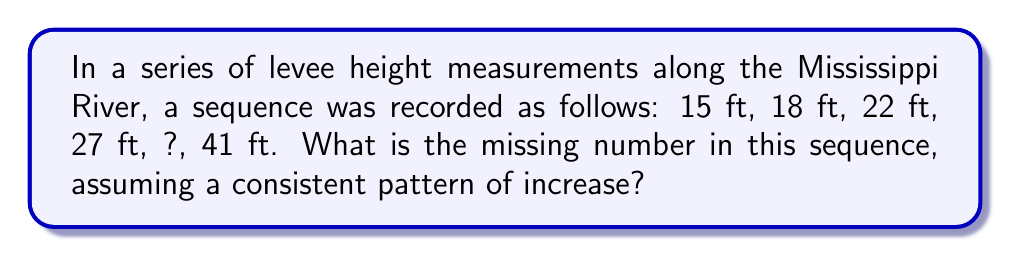Can you solve this math problem? To solve this problem, let's follow these steps:

1) First, we need to identify the pattern in the sequence. Let's calculate the differences between consecutive terms:

   18 - 15 = 3
   22 - 18 = 4
   27 - 22 = 5
   ? - 27 = ?
   41 - ? = ?

2) We can see that the difference is increasing by 1 each time:
   3, 4, 5, ...

3) Following this pattern, the next difference should be 6:
   27 + 6 = 33

4) To verify, let's check if the last difference is 7:
   41 - 33 = 8

5) Indeed, the pattern continues as the difference between the last two terms is 8.

Therefore, the missing number in the sequence is 33 ft.

This pattern of increasing differences is known as a quadratic sequence, which can be represented by a quadratic function. The general form is:

$$ a_n = an^2 + bn + c $$

Where $a_n$ is the nth term, and a, b, and c are constants.
Answer: 33 ft 